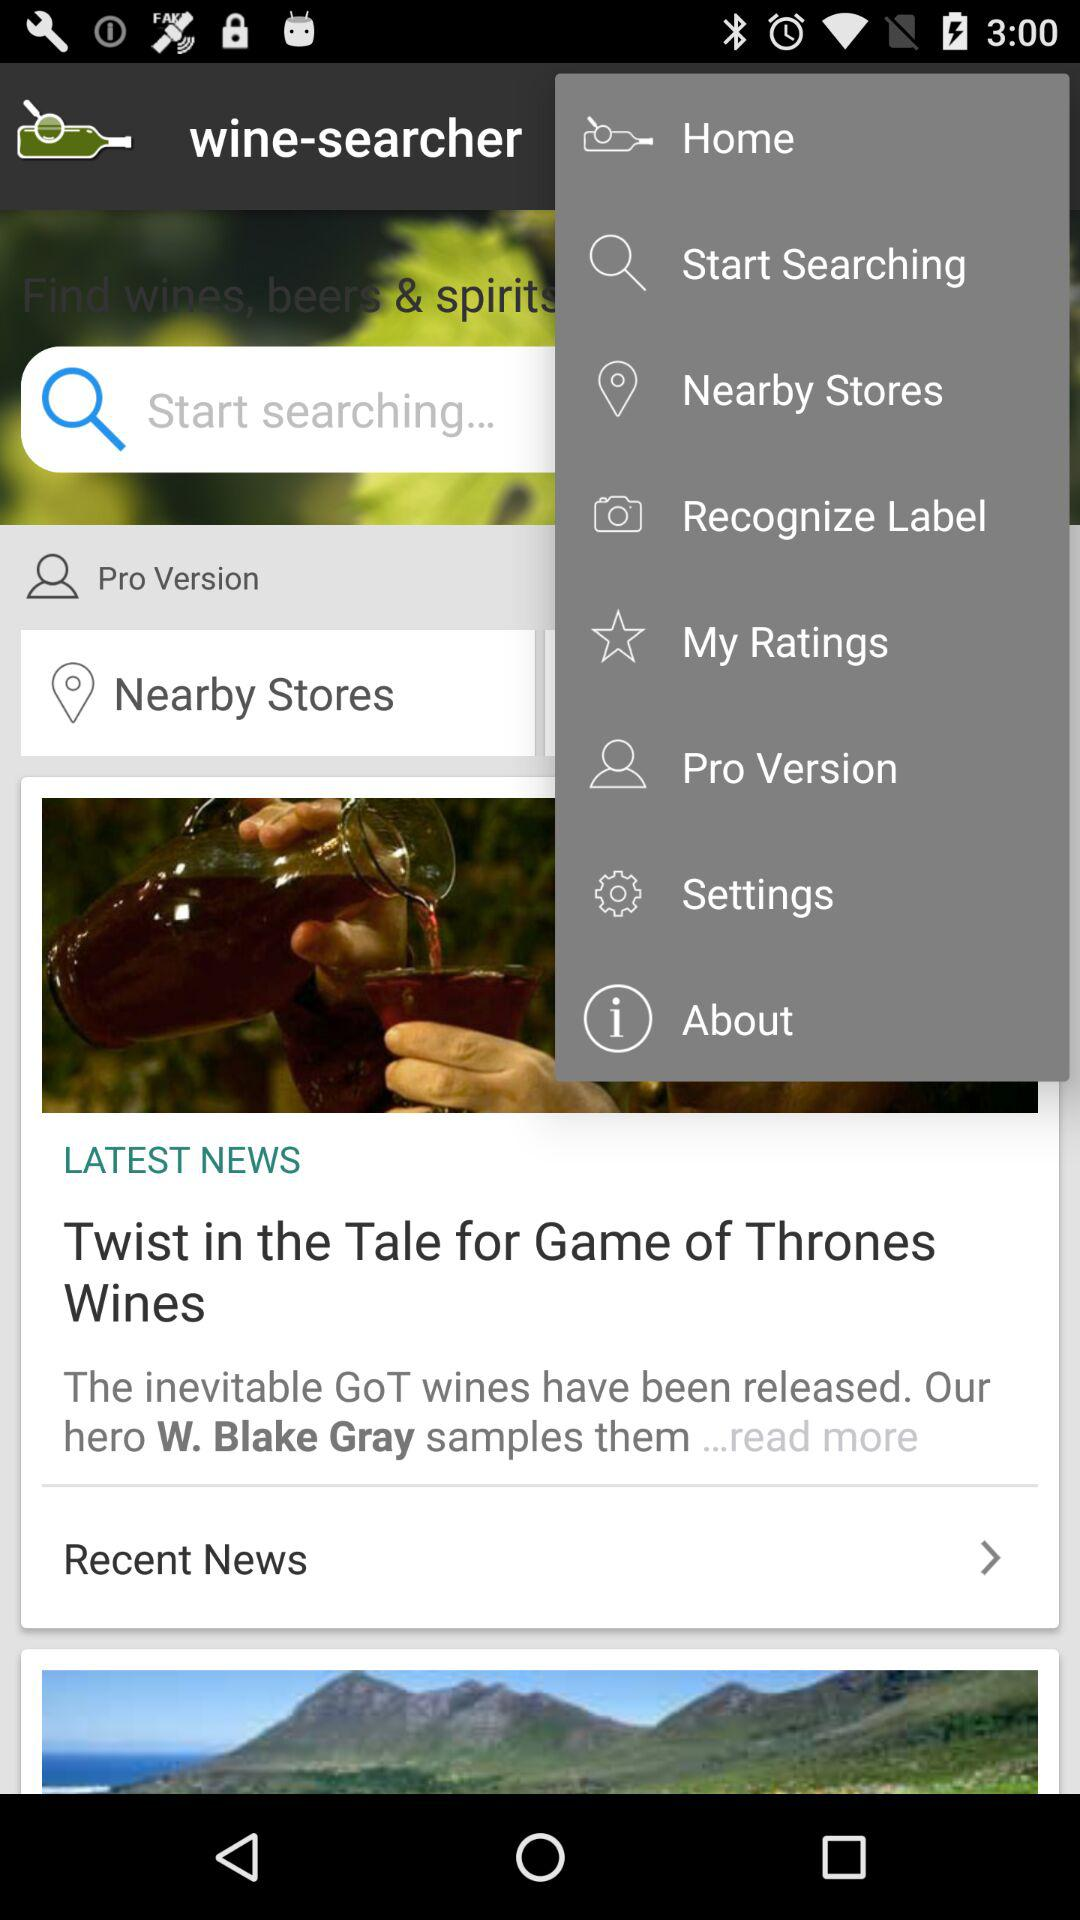What is the latest news displayed? The latest news is "Twist in the Tale for Game of Thrones Wines". 